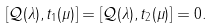Convert formula to latex. <formula><loc_0><loc_0><loc_500><loc_500>[ \mathcal { Q } ( \lambda ) , t _ { 1 } ( \mu ) ] = [ \mathcal { Q } ( \lambda ) , t _ { 2 } ( \mu ) ] = 0 .</formula> 